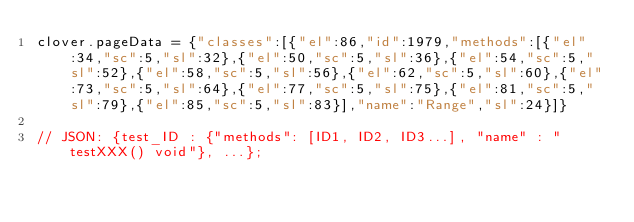Convert code to text. <code><loc_0><loc_0><loc_500><loc_500><_JavaScript_>clover.pageData = {"classes":[{"el":86,"id":1979,"methods":[{"el":34,"sc":5,"sl":32},{"el":50,"sc":5,"sl":36},{"el":54,"sc":5,"sl":52},{"el":58,"sc":5,"sl":56},{"el":62,"sc":5,"sl":60},{"el":73,"sc":5,"sl":64},{"el":77,"sc":5,"sl":75},{"el":81,"sc":5,"sl":79},{"el":85,"sc":5,"sl":83}],"name":"Range","sl":24}]}

// JSON: {test_ID : {"methods": [ID1, ID2, ID3...], "name" : "testXXX() void"}, ...};</code> 